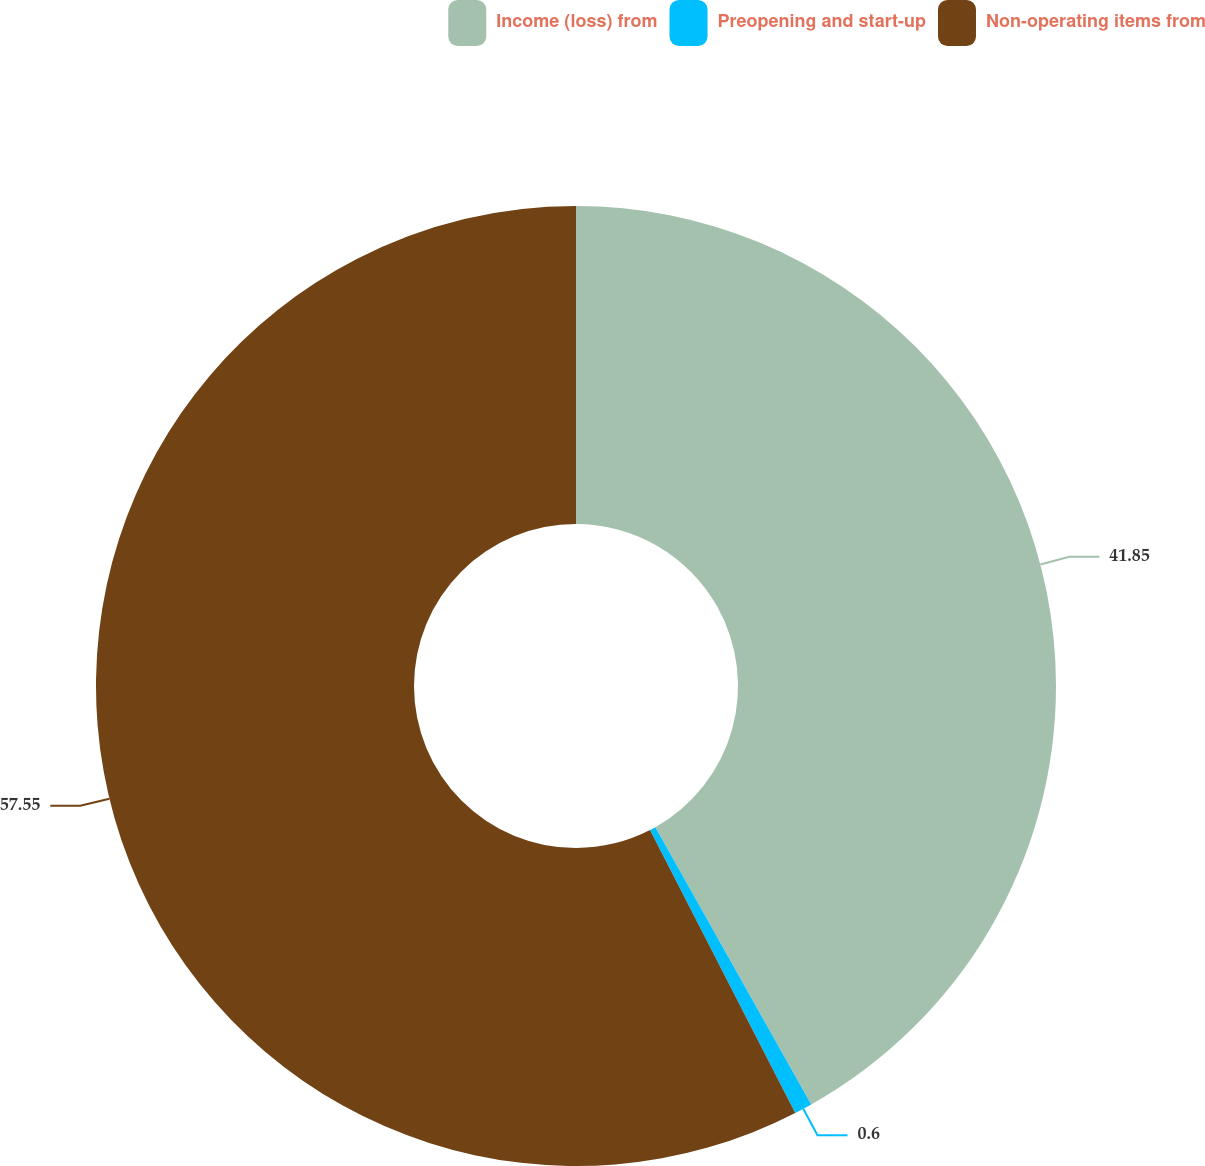Convert chart to OTSL. <chart><loc_0><loc_0><loc_500><loc_500><pie_chart><fcel>Income (loss) from<fcel>Preopening and start-up<fcel>Non-operating items from<nl><fcel>41.85%<fcel>0.6%<fcel>57.55%<nl></chart> 